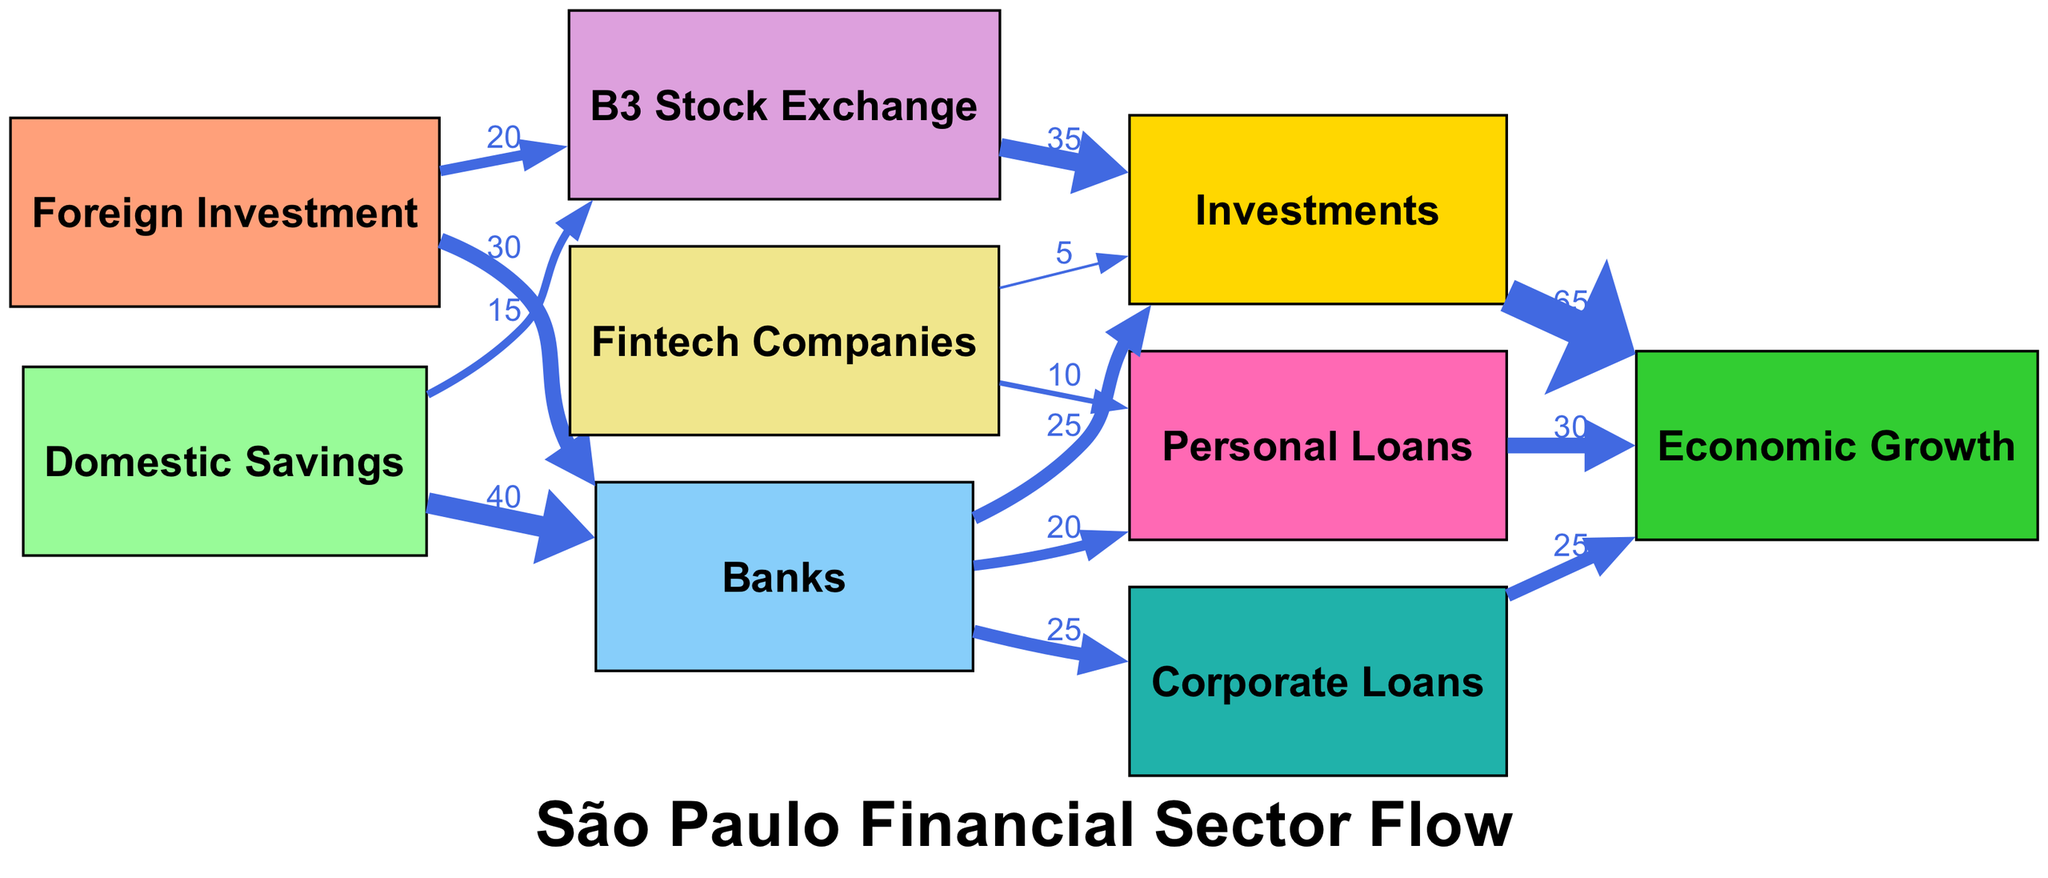What is the total value of foreign investment directed to banks? The diagram indicates that foreign investment flowing to banks has a value of 30. Since this is a direct flow from the foreign investment node to the banks node, the value can be directly read from the edge connecting these two nodes.
Answer: 30 How many nodes are present in the diagram? The diagram contains a total of 9 nodes, which are: foreign investment, domestic savings, banks, stock exchange, fintech companies, corporate loans, personal loans, investments, and economic growth. Counting each listed node gives the total number.
Answer: 9 What is the value of personal loans directed towards economic growth? The diagram shows that personal loans directed to economic growth has a value of 30. This is indicated by the edge connecting the personal loans node to the economic growth node.
Answer: 30 Which node receives the highest value from investments? The node receiving the highest value from investments is economic growth, with a value of 65 shown on the edge connecting investments to economic growth. This indicates the flow from investment to the resulting economic growth.
Answer: Economic Growth How much flow do banks send towards investments? According to the diagram, banks direct 25 towards investments. This value is found on the edge that connects the banks node to the investments node.
Answer: 25 What is the total contribution of corporate loans and personal loans to economic growth? To find the total contribution to economic growth, we need to add the values of corporate loans (25) and personal loans (30). Therefore, the total contribution is 25 + 30 = 55, combining the flows from both nodes to the economic growth node.
Answer: 55 What percentage of foreign investment goes to the B3 Stock Exchange? From the diagram, foreign investment directed to the B3 Stock Exchange has a value of 20. The total foreign investment directed to all nodes (30 + 20) is 50. The percentage can be calculated by (20 / 50) * 100 = 40%. This indicates the proportion of foreign investment that goes specifically to the stock exchange.
Answer: 40% Which node plays a role in both personal loans and investments? The banks node plays this dual role, as it sends flows to both personal loans (20) and investments (25). Thus, it acts as an intermediary for these two financial pathways.
Answer: Banks 